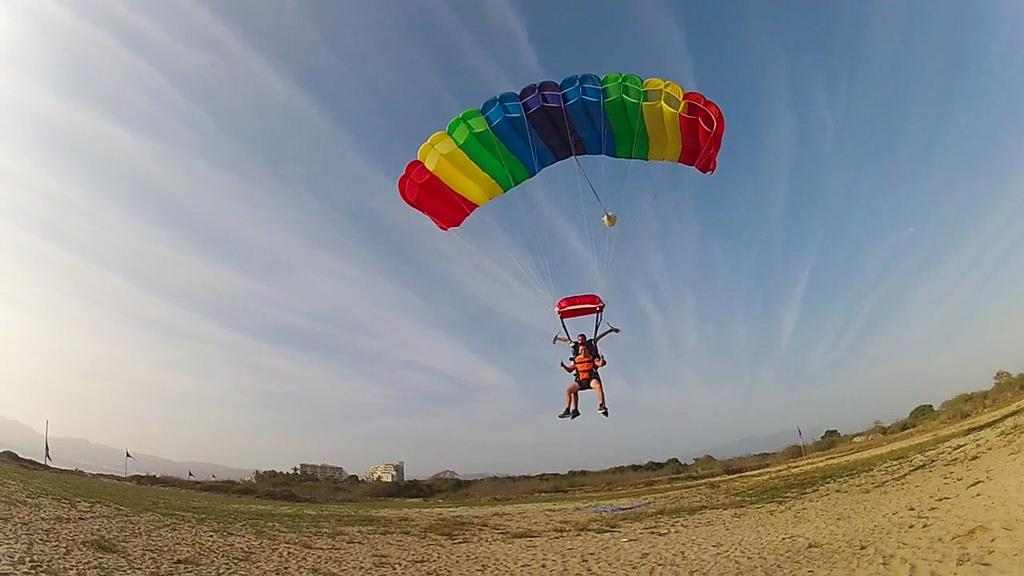How many people are in the image? There are two persons in the image. What are the persons doing in the image? The persons are using parachutes. What can be seen in the background of the image? There is a group of poles and trees in the background of the image. What is visible in the sky in the image? The sky is visible in the background of the image. What type of bubble can be seen floating near the persons in the image? There is no bubble present in the image; the persons are using parachutes. What kind of patch is visible on the hall in the image? There is no hall present in the image, only the sky, trees, and poles in the background. 